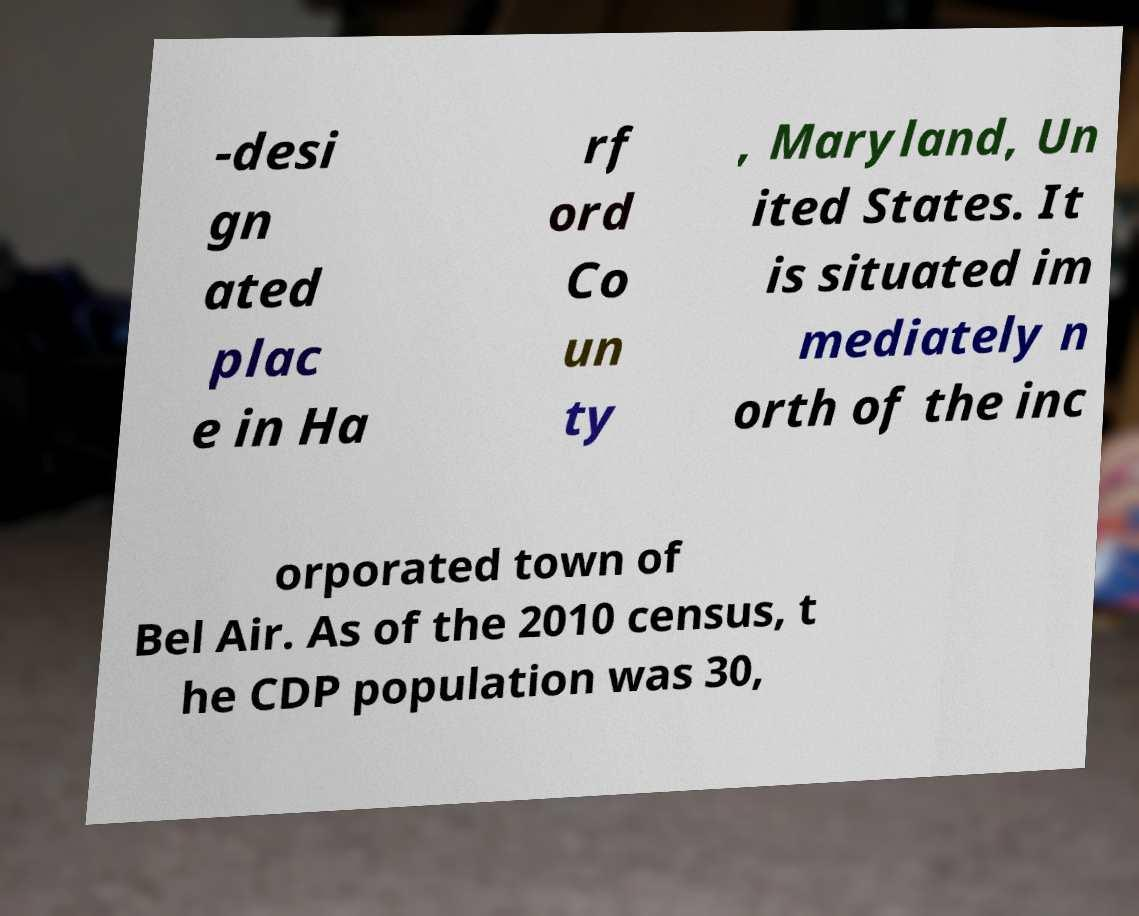What messages or text are displayed in this image? I need them in a readable, typed format. -desi gn ated plac e in Ha rf ord Co un ty , Maryland, Un ited States. It is situated im mediately n orth of the inc orporated town of Bel Air. As of the 2010 census, t he CDP population was 30, 